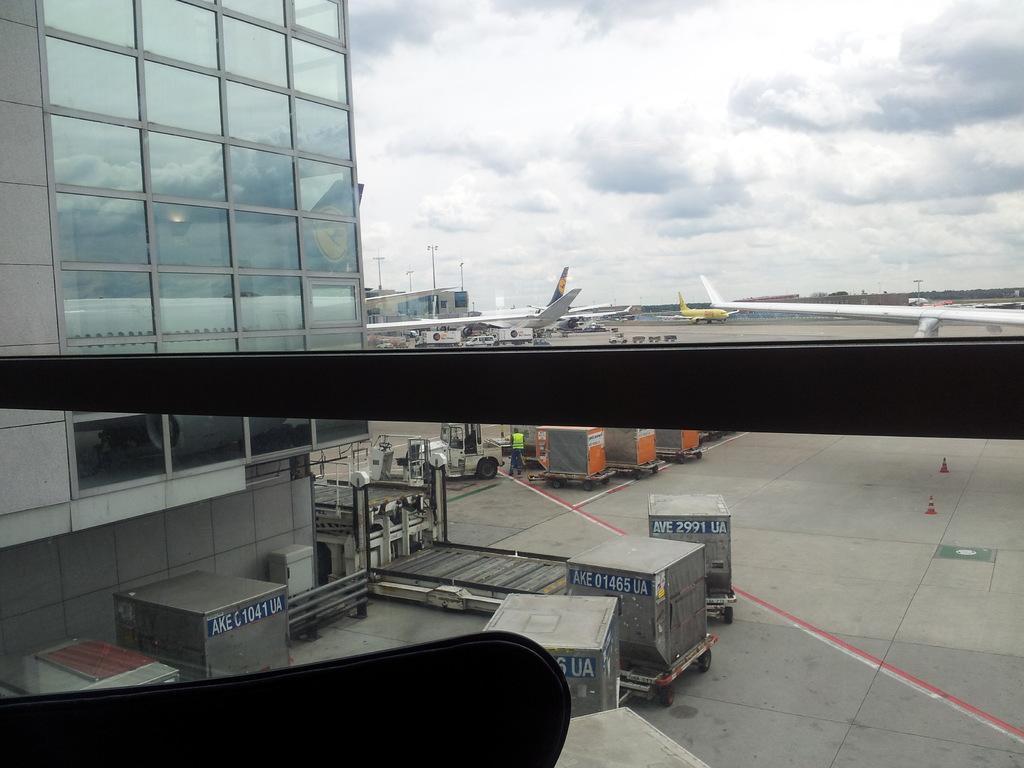Could you give a brief overview of what you see in this image? As we can see in the image there are vehicles, buildings, planes, traffic cones, sky and clouds. 